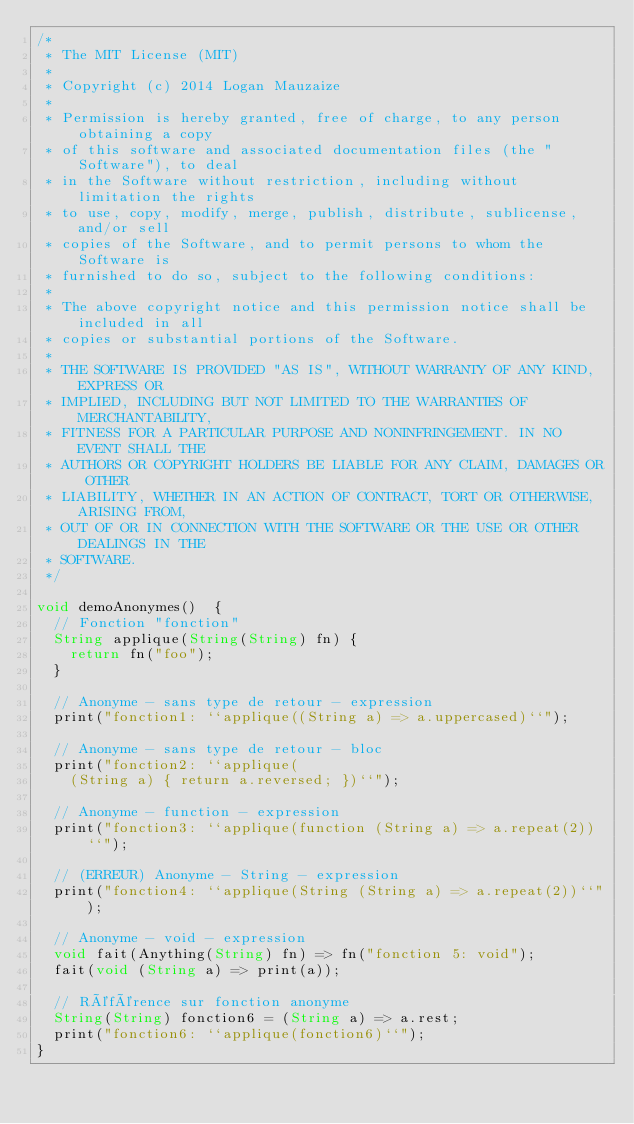Convert code to text. <code><loc_0><loc_0><loc_500><loc_500><_Ceylon_>/*
 * The MIT License (MIT)
 * 
 * Copyright (c) 2014 Logan Mauzaize
 * 
 * Permission is hereby granted, free of charge, to any person obtaining a copy
 * of this software and associated documentation files (the "Software"), to deal
 * in the Software without restriction, including without limitation the rights
 * to use, copy, modify, merge, publish, distribute, sublicense, and/or sell
 * copies of the Software, and to permit persons to whom the Software is
 * furnished to do so, subject to the following conditions:
 *
 * The above copyright notice and this permission notice shall be included in all
 * copies or substantial portions of the Software.
 *
 * THE SOFTWARE IS PROVIDED "AS IS", WITHOUT WARRANTY OF ANY KIND, EXPRESS OR
 * IMPLIED, INCLUDING BUT NOT LIMITED TO THE WARRANTIES OF MERCHANTABILITY,
 * FITNESS FOR A PARTICULAR PURPOSE AND NONINFRINGEMENT. IN NO EVENT SHALL THE
 * AUTHORS OR COPYRIGHT HOLDERS BE LIABLE FOR ANY CLAIM, DAMAGES OR OTHER
 * LIABILITY, WHETHER IN AN ACTION OF CONTRACT, TORT OR OTHERWISE, ARISING FROM,
 * OUT OF OR IN CONNECTION WITH THE SOFTWARE OR THE USE OR OTHER DEALINGS IN THE
 * SOFTWARE.
 */

void demoAnonymes()  {
  // Fonction "fonction"
  String applique(String(String) fn) {
    return fn("foo");
  }

  // Anonyme - sans type de retour - expression
  print("fonction1: ``applique((String a) => a.uppercased)``");

  // Anonyme - sans type de retour - bloc
  print("fonction2: ``applique(
    (String a) { return a.reversed; })``");

  // Anonyme - function - expression
  print("fonction3: ``applique(function (String a) => a.repeat(2))``");

  // (ERREUR) Anonyme - String - expression
  print("fonction4: ``applique(String (String a) => a.repeat(2))``");

  // Anonyme - void - expression
  void fait(Anything(String) fn) => fn("fonction 5: void");
  fait(void (String a) => print(a));

  // Référence sur fonction anonyme
  String(String) fonction6 = (String a) => a.rest;
  print("fonction6: ``applique(fonction6)``");
}
</code> 